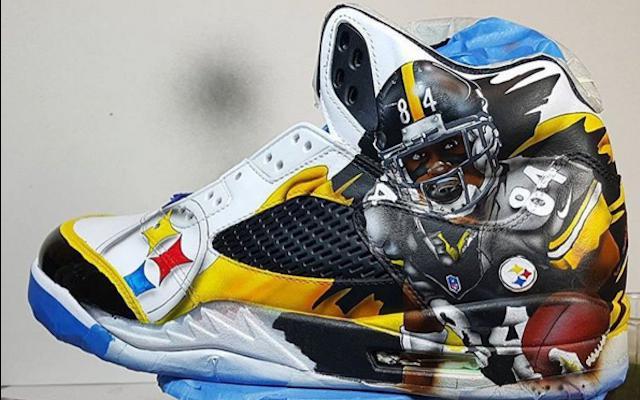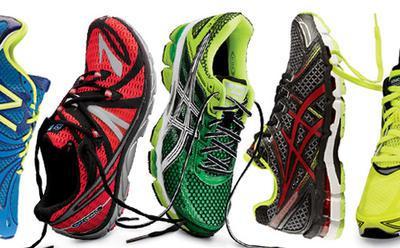The first image is the image on the left, the second image is the image on the right. Given the left and right images, does the statement "The left image shows at least a dozen shoe pairs arranged on a wood floor, and the right image shows a messy pile of sneakers." hold true? Answer yes or no. No. The first image is the image on the left, the second image is the image on the right. For the images shown, is this caption "There are fifteen pairs of shoes in the left image." true? Answer yes or no. No. 